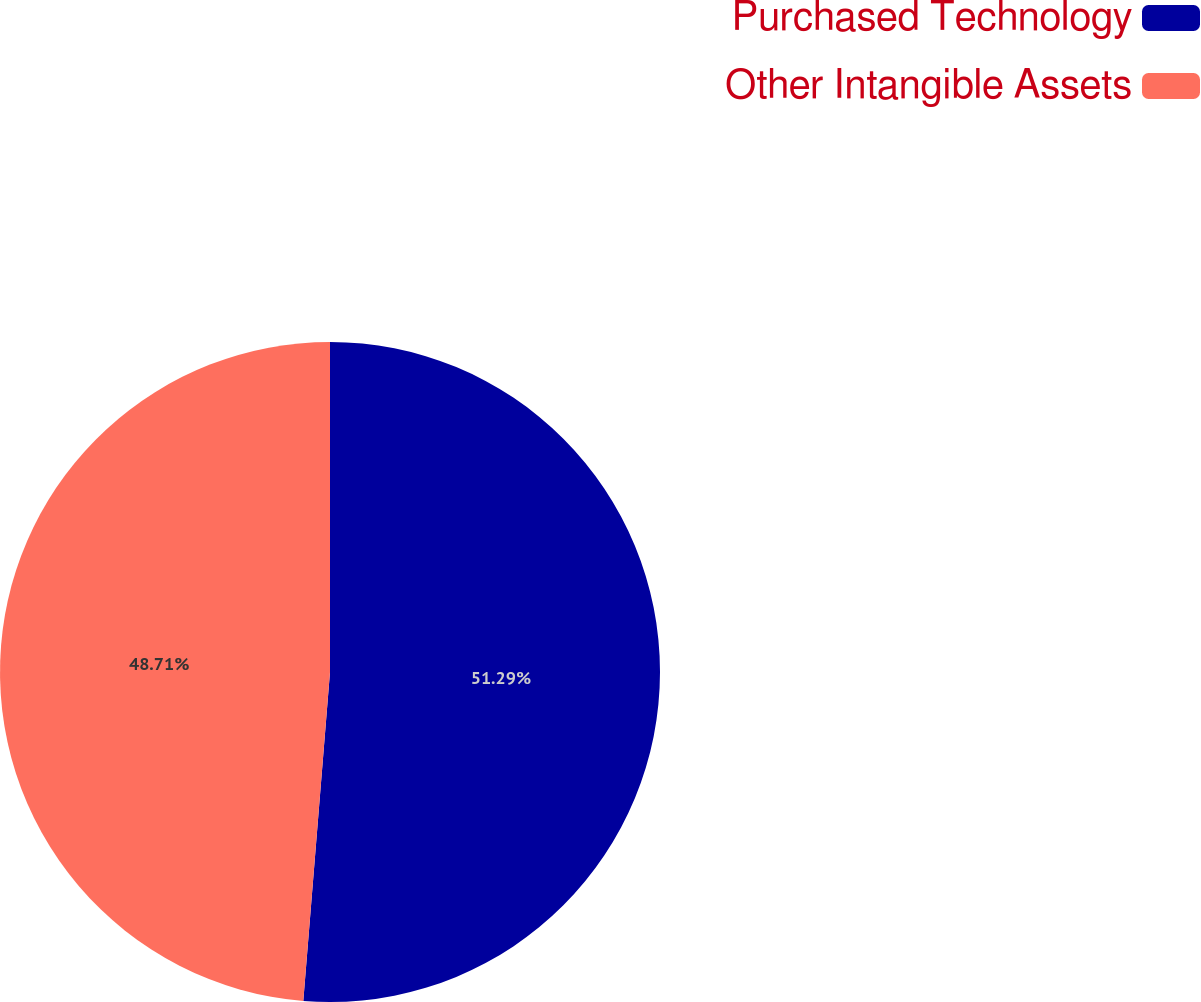Convert chart. <chart><loc_0><loc_0><loc_500><loc_500><pie_chart><fcel>Purchased Technology<fcel>Other Intangible Assets<nl><fcel>51.29%<fcel>48.71%<nl></chart> 